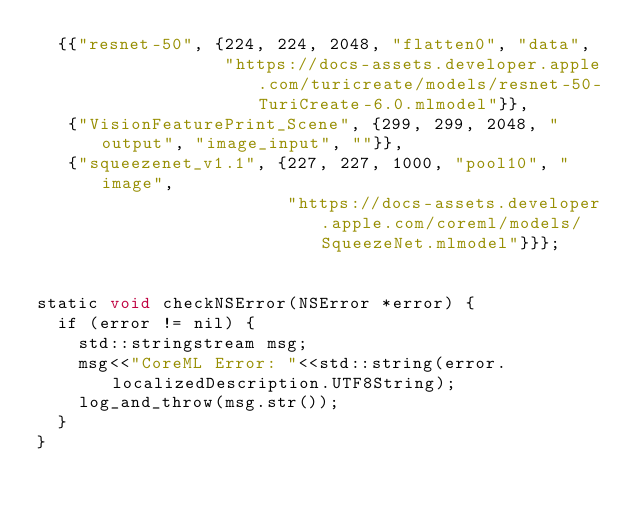Convert code to text. <code><loc_0><loc_0><loc_500><loc_500><_ObjectiveC_>  {{"resnet-50", {224, 224, 2048, "flatten0", "data",
                  "https://docs-assets.developer.apple.com/turicreate/models/resnet-50-TuriCreate-6.0.mlmodel"}},
   {"VisionFeaturePrint_Scene", {299, 299, 2048, "output", "image_input", ""}},
   {"squeezenet_v1.1", {227, 227, 1000, "pool10", "image",
                        "https://docs-assets.developer.apple.com/coreml/models/SqueezeNet.mlmodel"}}};


static void checkNSError(NSError *error) {
  if (error != nil) {
    std::stringstream msg;
    msg<<"CoreML Error: "<<std::string(error.localizedDescription.UTF8String);
    log_and_throw(msg.str());
  }
}

</code> 